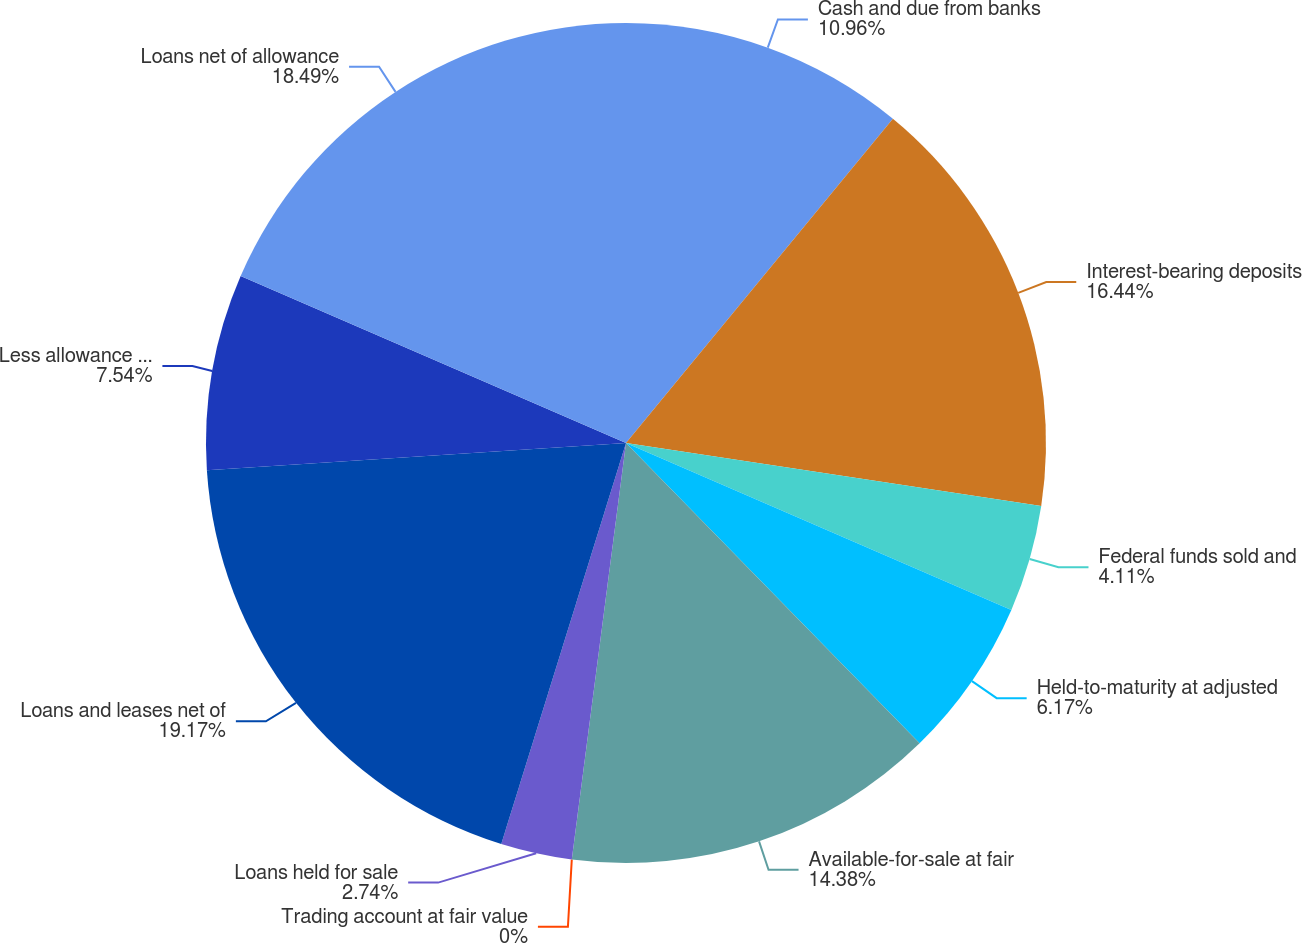Convert chart. <chart><loc_0><loc_0><loc_500><loc_500><pie_chart><fcel>Cash and due from banks<fcel>Interest-bearing deposits<fcel>Federal funds sold and<fcel>Held-to-maturity at adjusted<fcel>Available-for-sale at fair<fcel>Trading account at fair value<fcel>Loans held for sale<fcel>Loans and leases net of<fcel>Less allowance for loan losses<fcel>Loans net of allowance<nl><fcel>10.96%<fcel>16.44%<fcel>4.11%<fcel>6.17%<fcel>14.38%<fcel>0.0%<fcel>2.74%<fcel>19.17%<fcel>7.54%<fcel>18.49%<nl></chart> 